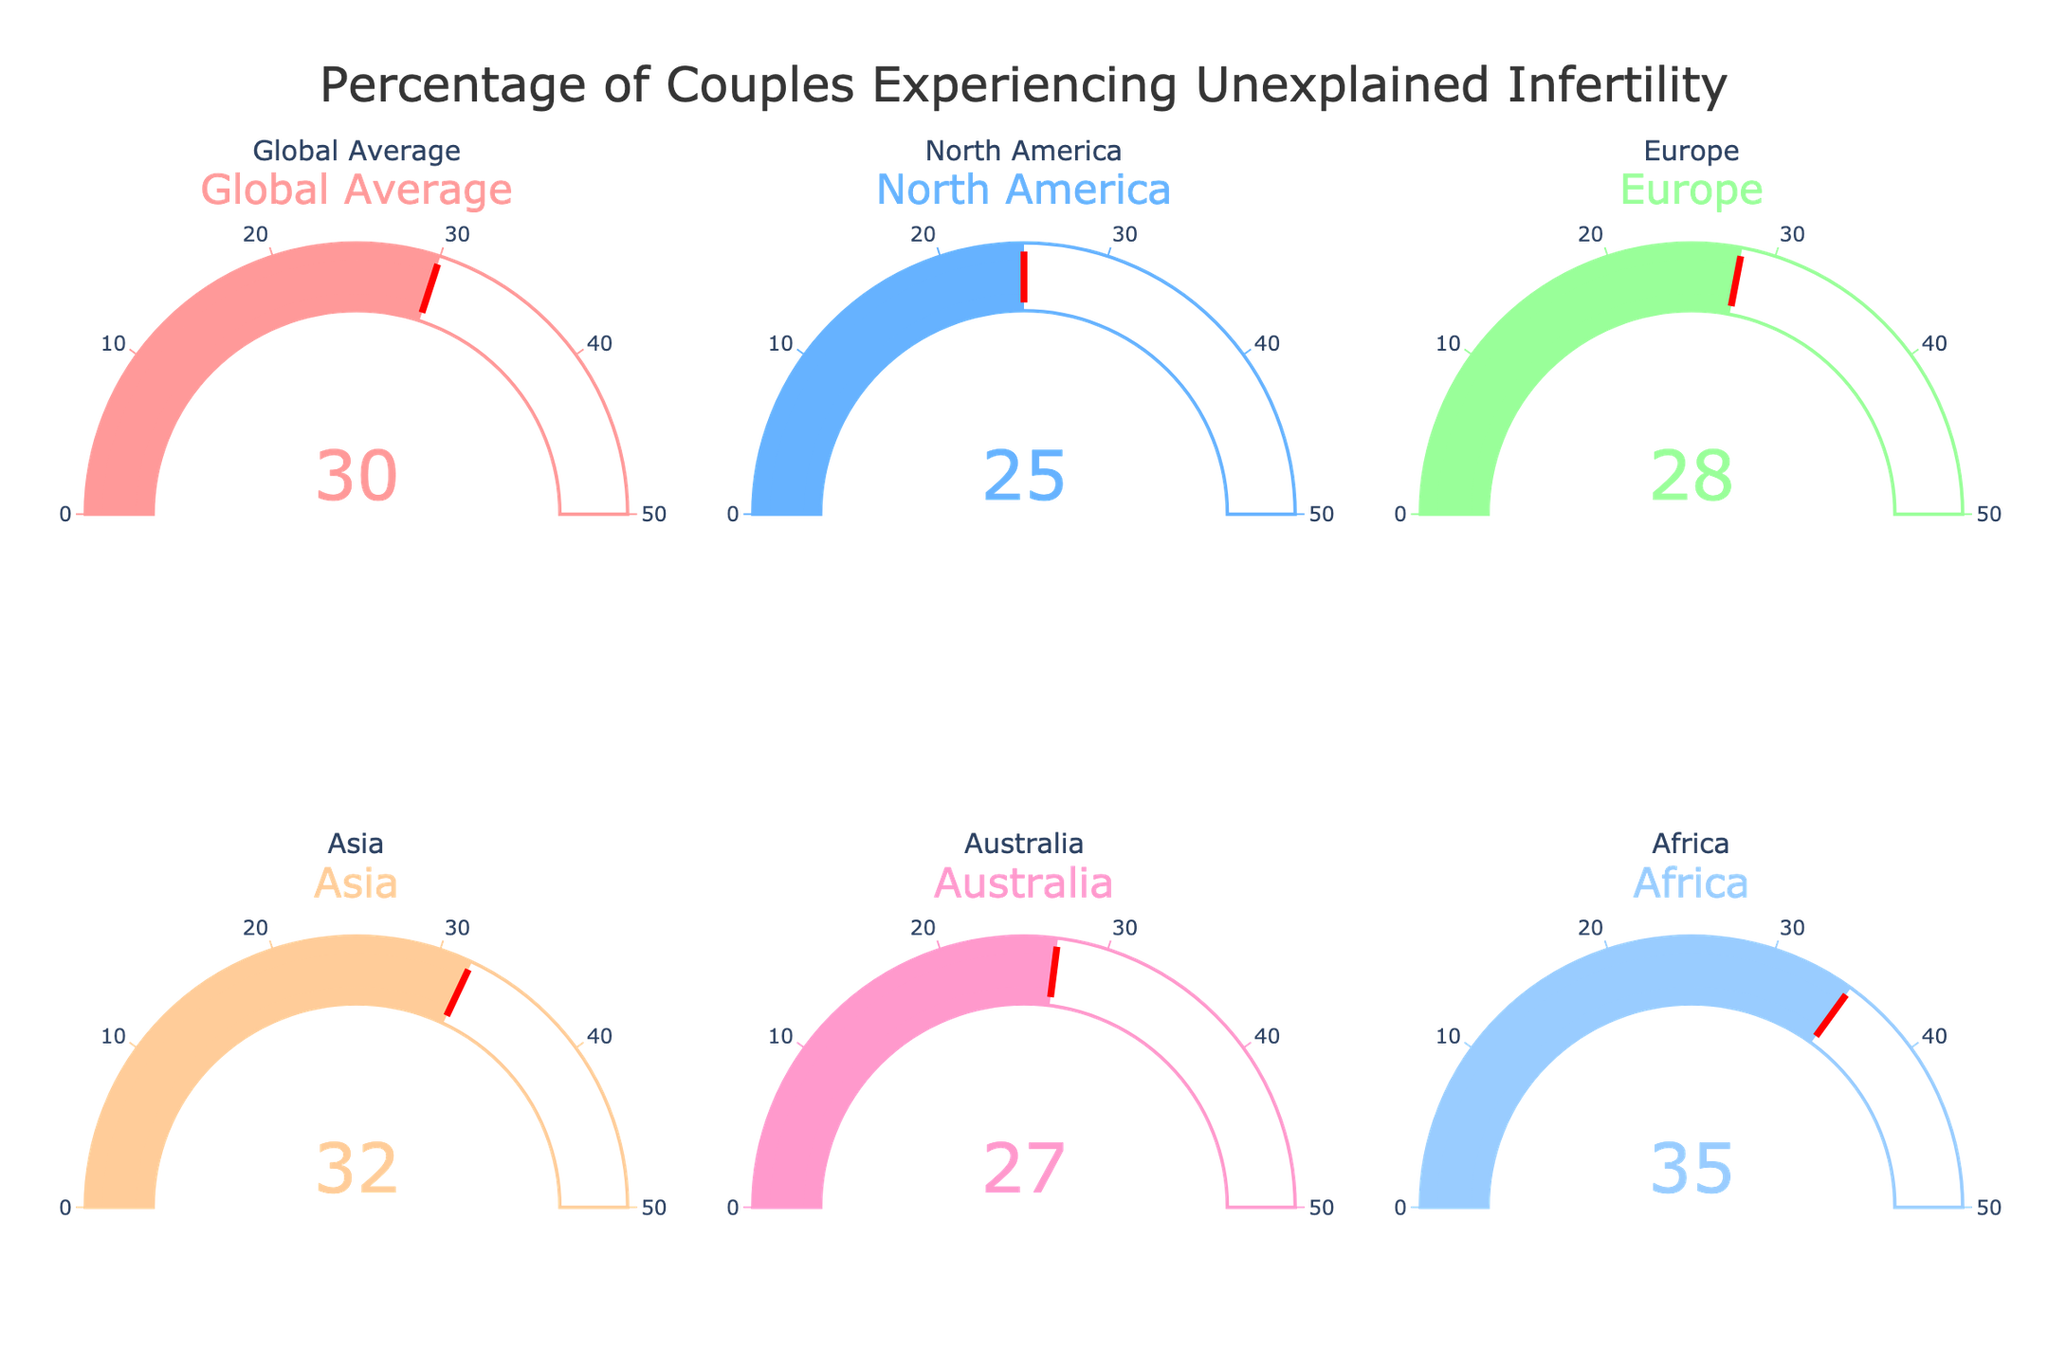What's the title of the figure? The title of the figure is displayed at the top of the chart.
Answer: "Percentage of Couples Experiencing Unexplained Infertility" How many regions are displayed in the figure? The figure contains six different gauges, each representing a region or category.
Answer: 6 Which region has the highest percentage of couples experiencing unexplained infertility? By looking at the gauge charts, the region with the highest percentage can be identified.
Answer: Africa Which region has the lowest percentage of couples experiencing unexplained infertility? By looking at the gauge charts, the region with the lowest percentage can be identified.
Answer: North America What is the percentage of couples experiencing unexplained infertility in Europe? The percentage for each region is shown on the gauge charts; find the one labeled "Europe."
Answer: 28% What is the total percentage of couples experiencing unexplained infertility across all regions combined? Add all the percentages from the gauge charts: 30 + 25 + 28 + 32 + 27 + 35.
Answer: 177% Which regions have a percentage higher than the global average? Compare each region's percentage to the global average (30%) shown in its gauge chart.
Answer: Asia and Africa What is the difference in the percentage of unexplained infertility between Asia and North America? Subtract the percentage for North America from the percentage for Asia (32 - 25).
Answer: 7% Is there any region where the percentage of unexplained infertility is equal to 27%? Check the gauge charts to see which, if any, regions have this exact percentage.
Answer: Australia On average, what percentage of couples experience unexplained infertility in North America and Europe? Calculate the average by adding North America's and Europe's percentages and dividing by 2 (25 + 28) / 2.
Answer: 26.5% 